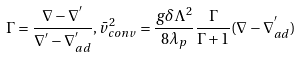<formula> <loc_0><loc_0><loc_500><loc_500>\Gamma = \frac { \nabla - \nabla ^ { ^ { \prime } } } { \nabla ^ { ^ { \prime } } - \nabla ^ { ^ { \prime } } _ { a d } } , \bar { v } _ { c o n v } ^ { 2 } = \frac { g \delta \Lambda ^ { 2 } } { 8 \lambda _ { p } } \frac { \Gamma } { \Gamma + 1 } ( \nabla - \nabla ^ { ^ { \prime } } _ { a d } )</formula> 